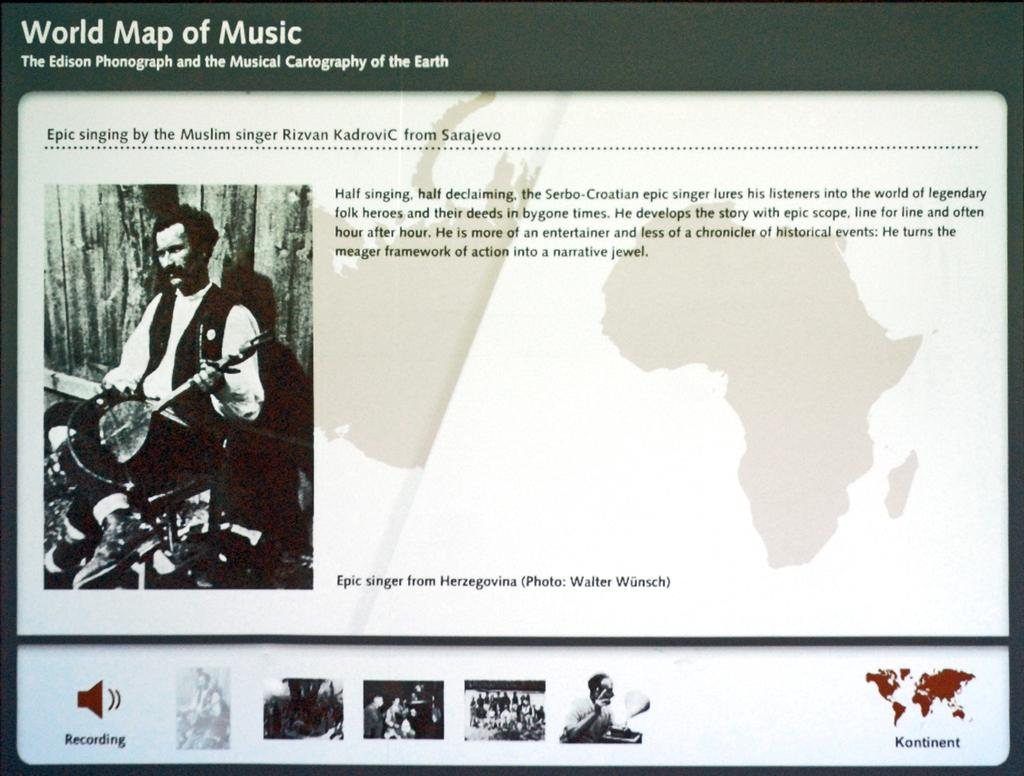What is the main object in the image? There is a poster in the image. What can be seen on the left side of the poster? The poster contains an image of a man on the left side. What type of content is present on the poster besides the image? There is a map and written content on the poster. Are there any other images on the poster besides the man? Yes, there are other images on the poster. How does the man's knee compare to the sock in the image? There is no man's knee or sock present in the image; it only contains a poster with an image of a man, a map, and written content. 